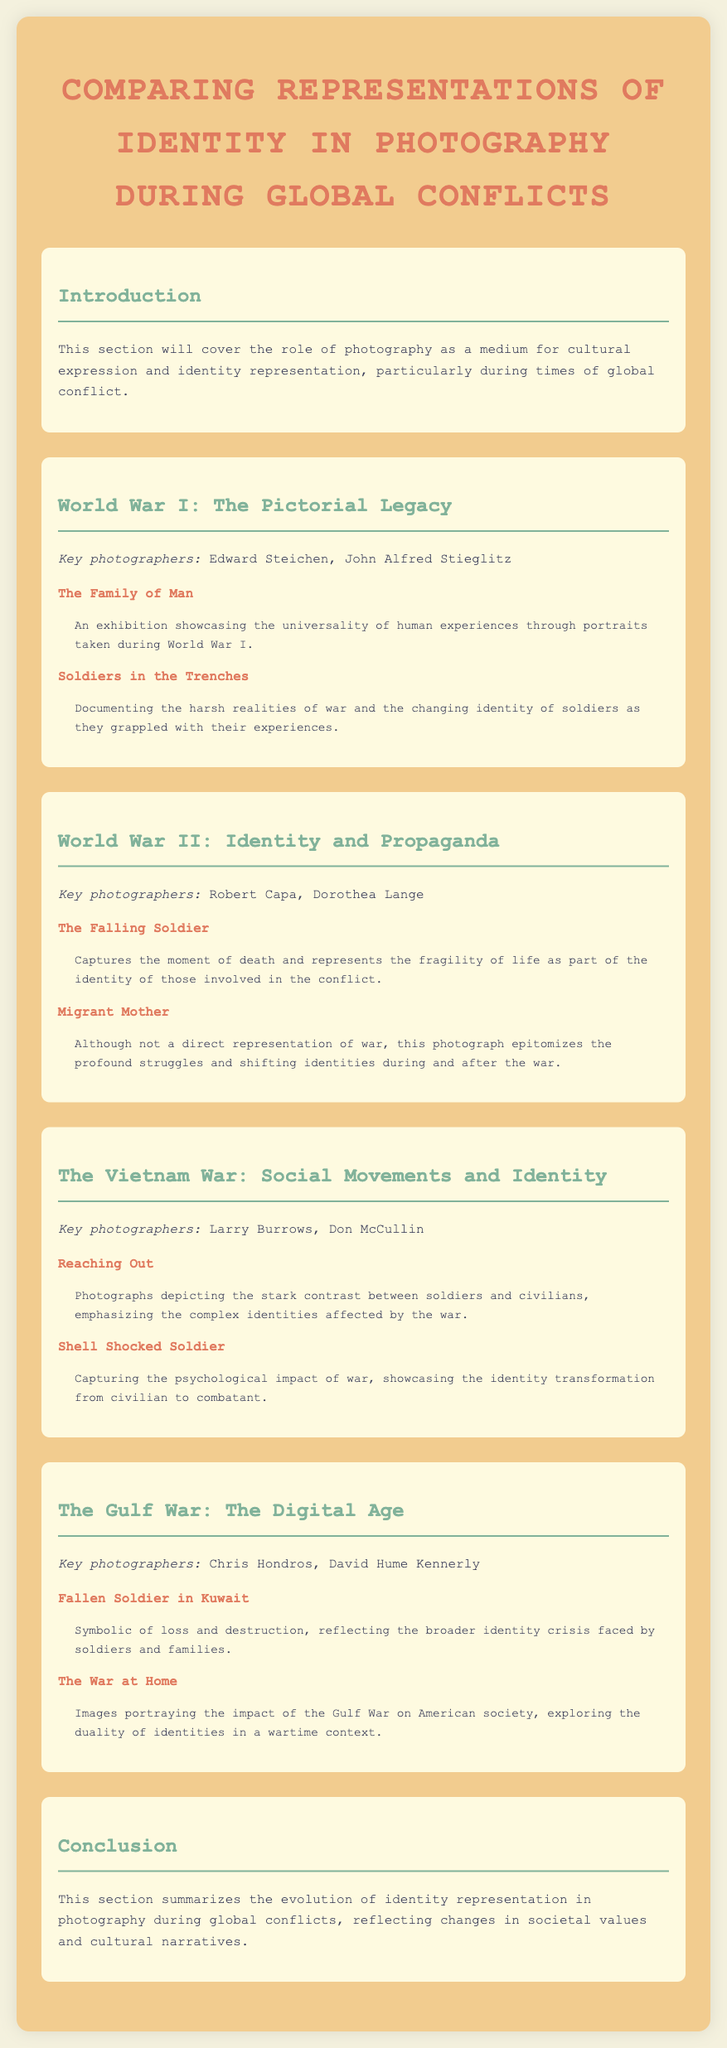What is the title of the document? The title of the document is provided at the top of the page and summarizes the content as it discusses photography during global conflicts.
Answer: Comparing Representations of Identity in Photography During Global Conflicts Who is a key photographer from World War II? The document lists several key photographers for World War II, which include Robert Capa and Dorothea Lange.
Answer: Robert Capa What is the work title associated with Edward Steichen? The document mentions two works associated with key photographers, one being "The Family of Man" linked to Edward Steichen.
Answer: The Family of Man What concept does the photograph "Migrant Mother" represent? This photograph symbolizes the struggles and shifting identities during and after World War II, reflecting the broader context of the time.
Answer: Profound struggles Which war is associated with Larry Burrows and Don McCullin? The section discusses the Vietnam War and highlights key photographers including Larry Burrows and Don McCullin as notable figures.
Answer: The Vietnam War How does the document categorize the Gulf War? The section discusses changes in photography associated with the digital era during global conflicts, specifically relating to the Gulf War.
Answer: The Digital Age What theme is prevalent in the photograph "Shell Shocked Soldier"? The document describes this photograph as capturing the psychological impact of war and the transformation of identity.
Answer: Psychological impact What is the overall focus of the document's conclusion? The conclusion summarizes the evolution of identity representation in photography, indicating changes in societal values and narratives over time.
Answer: Evolution of identity representation 